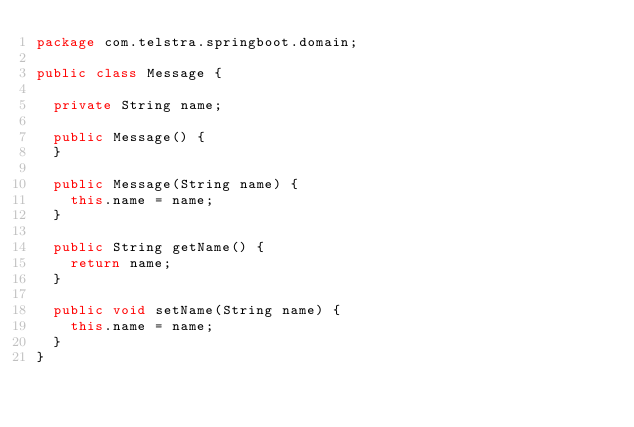Convert code to text. <code><loc_0><loc_0><loc_500><loc_500><_Java_>package com.telstra.springboot.domain;

public class Message {

	private String name;

	public Message() {
	}

	public Message(String name) {
		this.name = name;
	}

	public String getName() {
		return name;
	}

	public void setName(String name) {
		this.name = name;
	}
}
</code> 